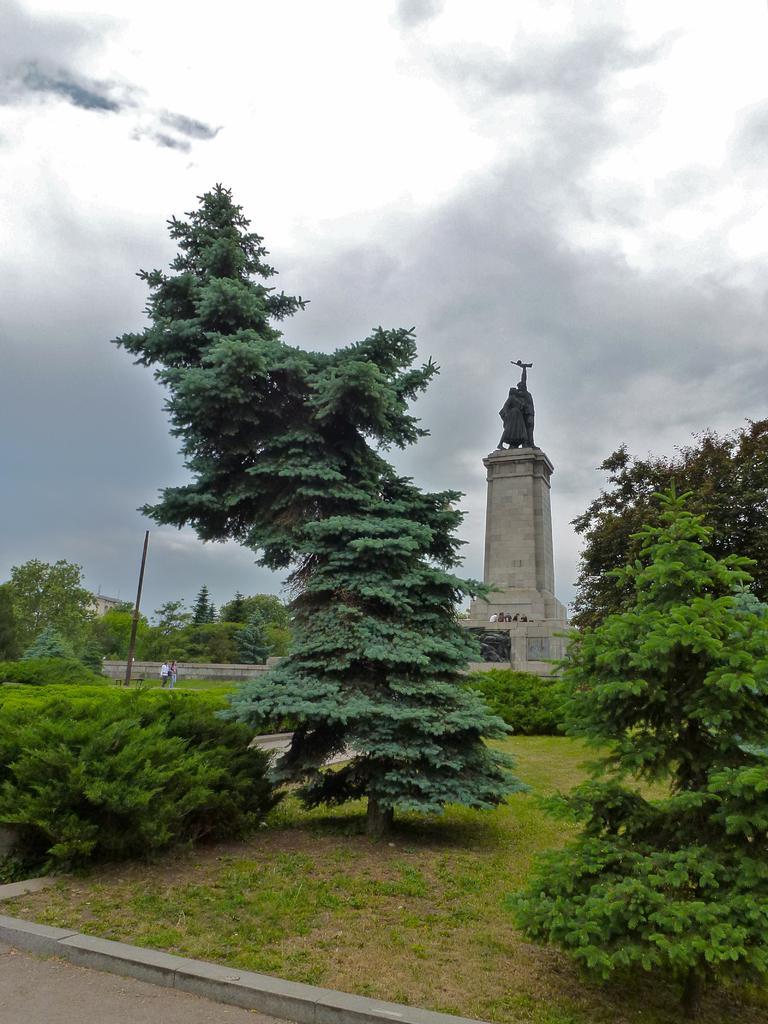Describe this image in one or two sentences. In this picture there are trees on the right and left side of the image, on the grassland, there are people in the background area of the image, there is a statue on a headstone in the background area of the image, there is a pole in the image. 